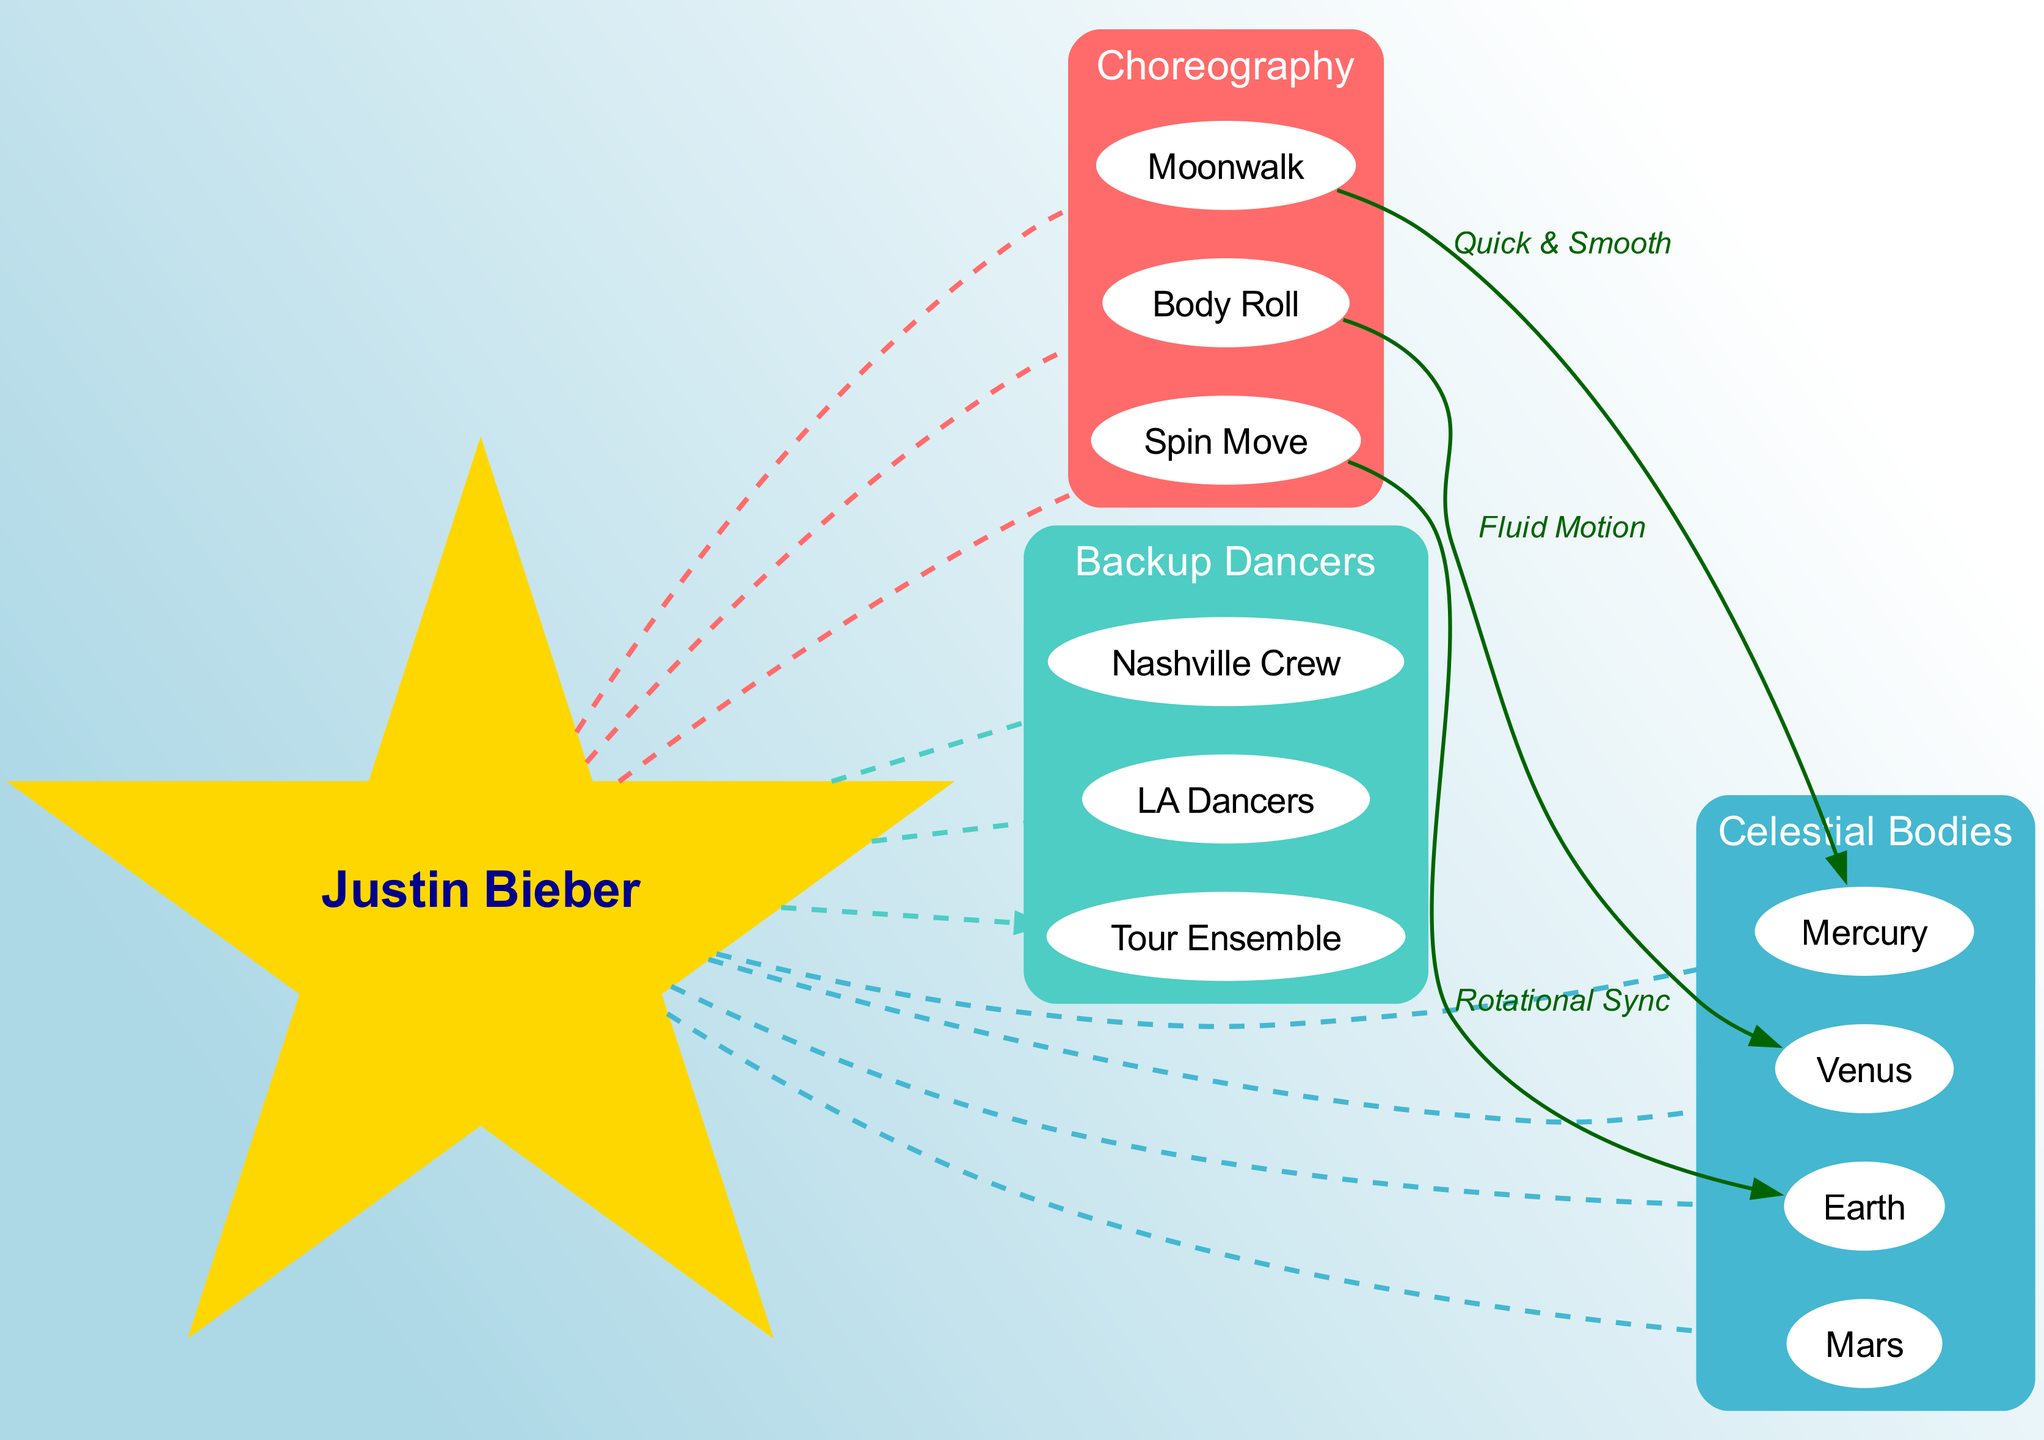What is at the center of the diagram? The diagram clearly labels Justin Bieber as the central figure, which serves as the focal point around which the other elements are arranged.
Answer: Justin Bieber How many elements are in the "Choreography" orbit? By looking at the "Choreography" orbit, we see three elements: Moonwalk, Body Roll, and Spin Move. Counting these gives us the total number of elements.
Answer: 3 What dance movement is linked to Mercury? The diagram indicates a connection labeled "Quick & Smooth" between the Moonwalk and Mercury, identifying Moonwalk as the specific dance movement linked to that planet.
Answer: Moonwalk Which celestial body is associated with the Spin Move? The diagram displays an edge connecting Spin Move to Earth, labeled "Rotational Sync," indicating that Earth is the celestial body associated with that dance.
Answer: Earth How many backup dancers are shown in the diagram? The "Backup Dancers" orbit contains three elements: Nashville Crew, LA Dancers, and Tour Ensemble. Therefore, we can conclude that there are a total of three backup dancers shown.
Answer: 3 What is the label connecting Body Roll to Venus? There is a connection depicted in the diagram from Body Roll to Venus with the label "Fluid Motion," which provides insight into the relationship between the dance movement and the celestial body.
Answer: Fluid Motion Which dance movement demonstrates "Rotational Sync"? The Spin Move is directly labeled with "Rotational Sync" in its connection to Earth, specifying that this particular movement exemplifies that quality with respect to the planet.
Answer: Spin Move Which celestial body is represented first in the "Celestial Bodies" orbit? In the diagram, the elements in the "Celestial Bodies" orbit are listed starting with Mercury, indicating that it is the first celestial body represented in that group.
Answer: Mercury What type of connections exist between Justin Bieber and the dance movements? The diagram shows dashed lines connecting Justin Bieber to the dance movements, indicating a relationship characterized as a 'movement' or 'performance connection' rather than a physical or direct one.
Answer: Dashed lines 